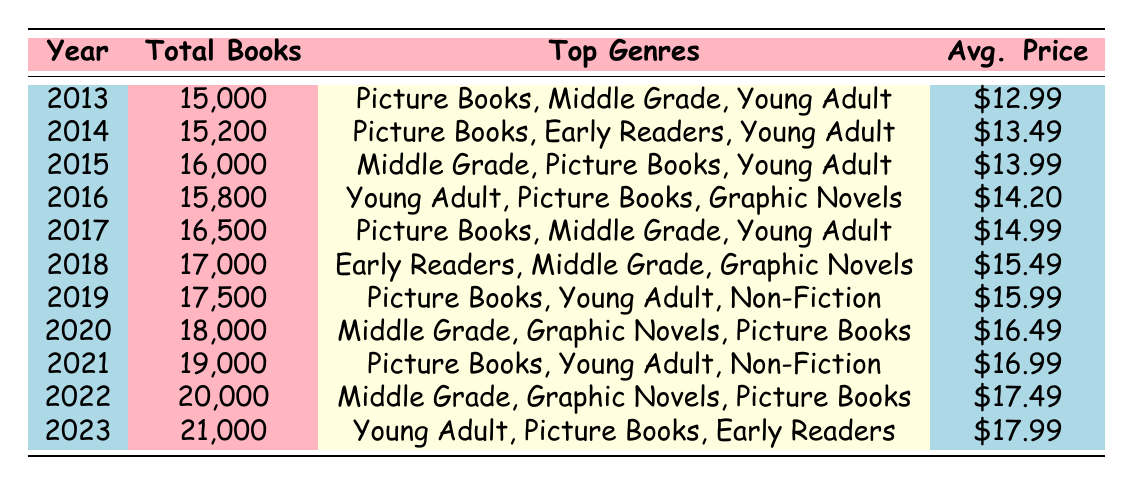What was the total number of children's books published in 2020? In the table, for the year 2020, the total number of books published is specifically listed as 18,000.
Answer: 18,000 Which year had the highest average price for children's books? By examining the average prices listed for each year, the year 2023 shows the highest average price at $17.99.
Answer: $17.99 In which year did children's book publishing first exceed 17,000 total books? The data indicates that the first year surpassing 17,000 total books is 2018 when 17,000 books were published.
Answer: 2018 What was the average price of children's books published in 2015 and 2016? The average price in 2015 is $13.99 and in 2016 is $14.20. To find the average of these two years, add them (13.99 + 14.20 = 28.19) and divide by 2, which equals 14.095.
Answer: $14.10 Which genres were consistently popular from 2013 to 2017? By reviewing the data for 2013 to 2017, the genres "Picture Books," "Middle Grade," and "Young Adult" appear in multiple years, indicating their consistent popularity.
Answer: Yes In the year 2022, how many books were published compared to 2014? In 2022, there were 20,000 books published and in 2014, 15,200 books were published. The difference is 20,000 - 15,200 = 4,800.
Answer: 4,800 What are the notable titles from 2019? Notable titles from 2019 listed in the table are "The Very Hungry Caterpillar," "The Hate U Give," and "The Wishing Spell."
Answer: The Very Hungry Caterpillar, The Hate U Give, The Wishing Spell In which year did the number of books published increase the most compared to the previous year? Analyzing the total books published per year, the increase from 2021 (19,000) to 2022 (20,000) is the most significant, with a rise of 1,000 books.
Answer: 1,000 books What is the trend in children's book publishing total from 2013 to 2023? Total books published increased from 15,000 in 2013 to 21,000 in 2023. This indicates a clear upward trend in children's book publishing over this period.
Answer: Increasing Were Graphic Novels among the top genres in 2014? The data for 2014 shows the top genres as "Picture Books," "Early Readers," and "Young Adult," with no mention of Graphic Novels, so it was not among the top genres that year.
Answer: No 